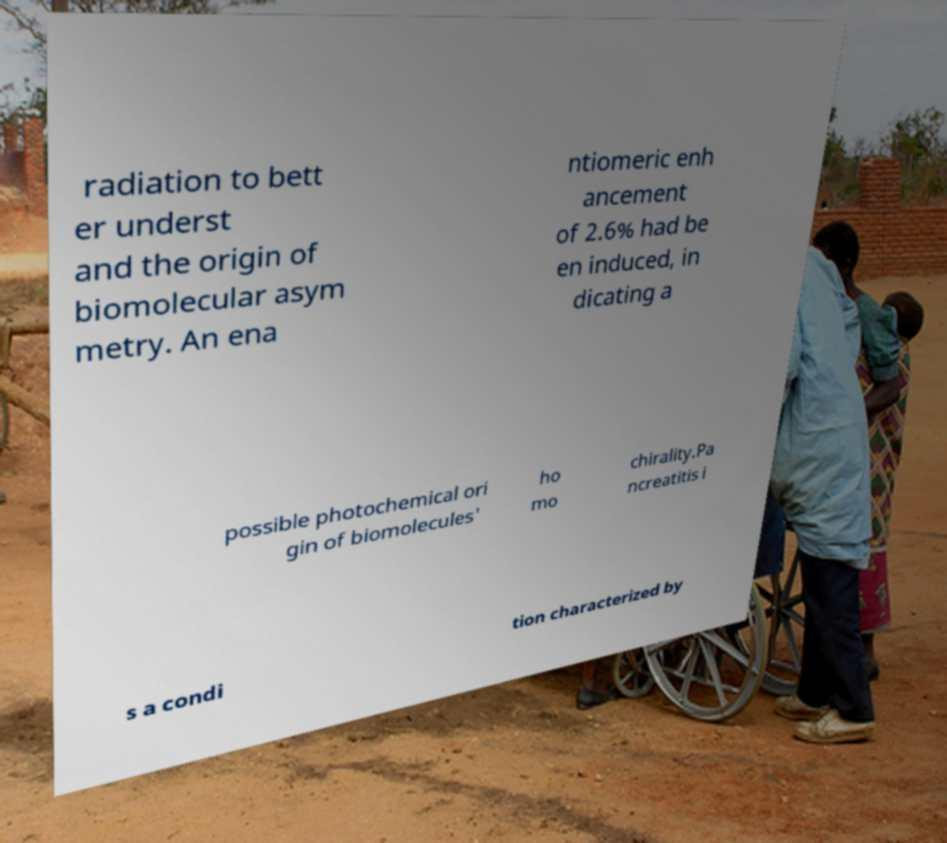For documentation purposes, I need the text within this image transcribed. Could you provide that? radiation to bett er underst and the origin of biomolecular asym metry. An ena ntiomeric enh ancement of 2.6% had be en induced, in dicating a possible photochemical ori gin of biomolecules' ho mo chirality.Pa ncreatitis i s a condi tion characterized by 